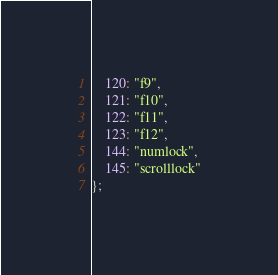Convert code to text. <code><loc_0><loc_0><loc_500><loc_500><_JavaScript_>    120: "f9",
    121: "f10",
    122: "f11",
    123: "f12",
    144: "numlock",
    145: "scrolllock"
};
</code> 